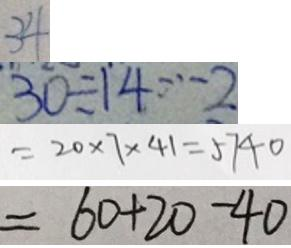Convert formula to latex. <formula><loc_0><loc_0><loc_500><loc_500>3 4 
 3 0 \div 1 4 \cdots 2 
 = 2 0 \times 7 \times 4 1 = 5 7 4 0 
 = 6 0 + 2 0 - 4 0</formula> 